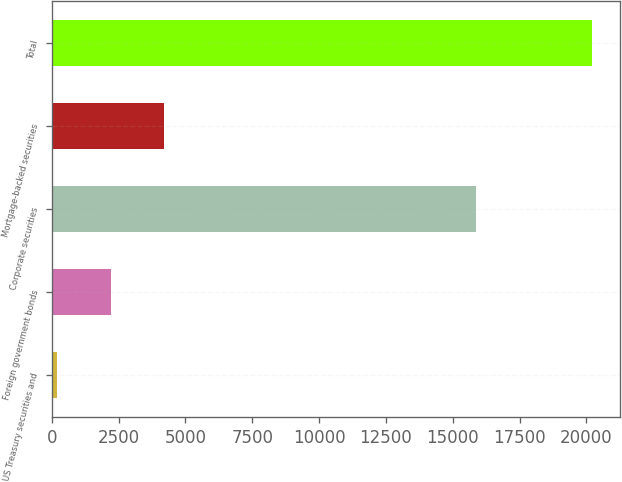Convert chart to OTSL. <chart><loc_0><loc_0><loc_500><loc_500><bar_chart><fcel>US Treasury securities and<fcel>Foreign government bonds<fcel>Corporate securities<fcel>Mortgage-backed securities<fcel>Total<nl><fcel>204<fcel>2206<fcel>15878<fcel>4208<fcel>20224<nl></chart> 